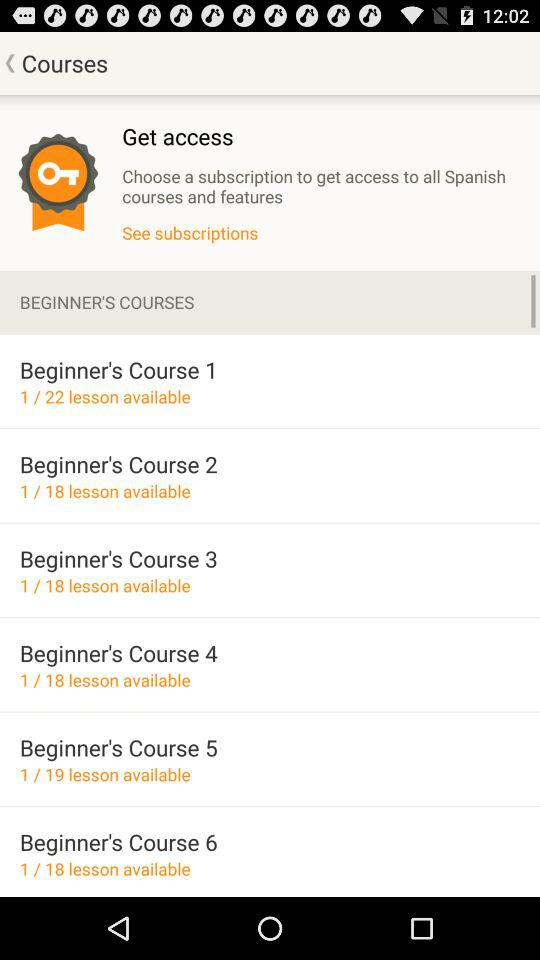How many beginner's courses are available?
Answer the question using a single word or phrase. 6 